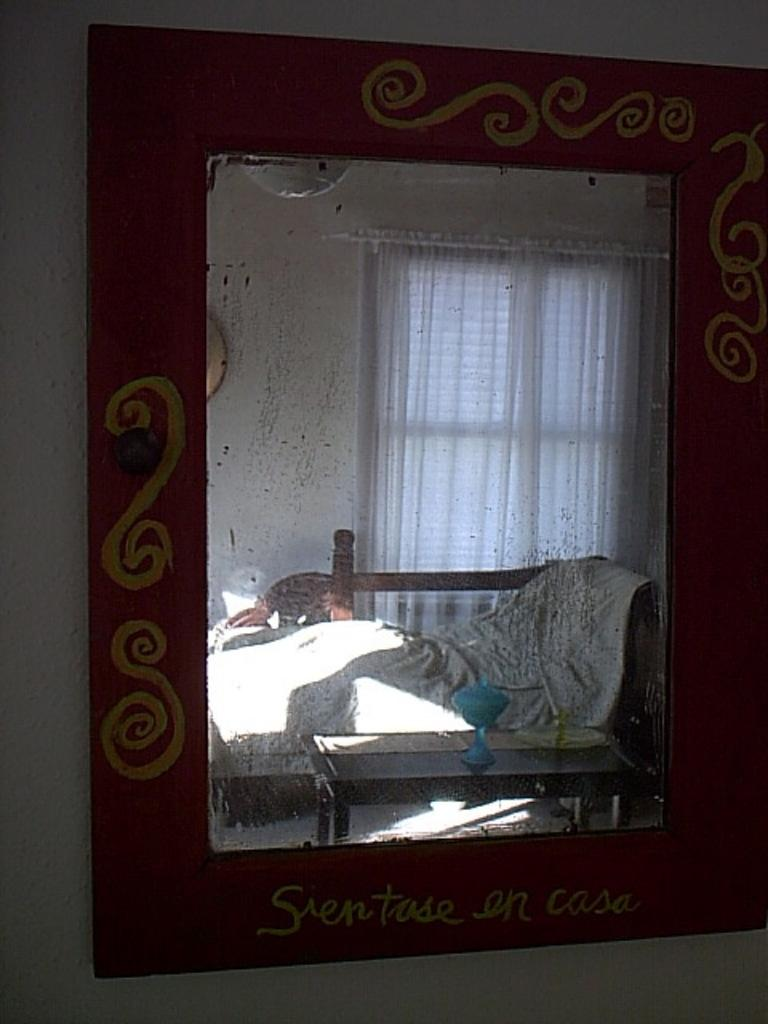What object is attached to the wall in the image? There is a mirror on the wall in the image. What does the mirror reflect in the image? The mirror reflects a sofa, a table, and curtains in the image. What type of horn can be seen on the table in the image? There is no horn present on the table in the image. What kind of property is visible in the mirror's reflection? The mirror's reflection does not show any property; it reflects a sofa, a table, and curtains. 